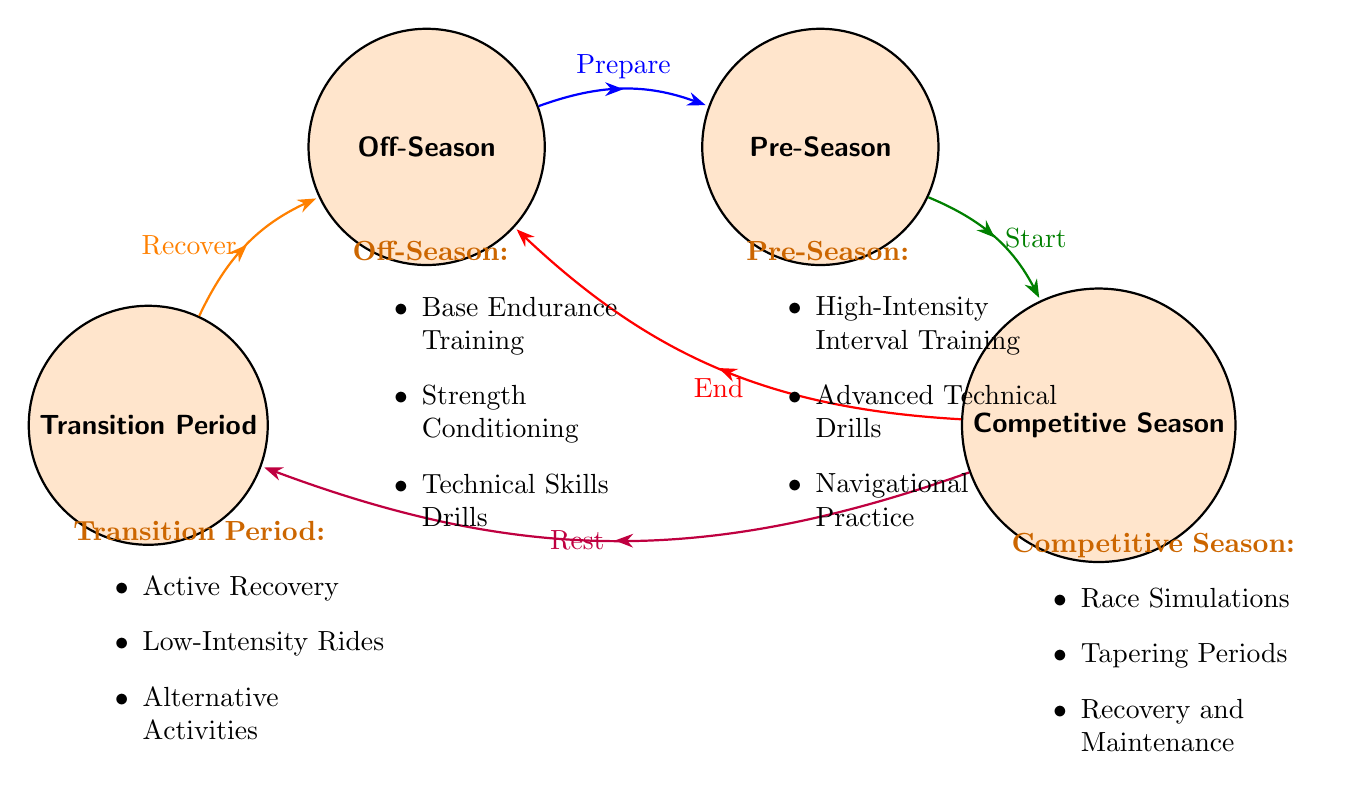What are the activities in the Off-Season? The Off-Season state lists three activities: Base Endurance Training, Strength Conditioning, and Technical Skills Drills.
Answer: Base Endurance Training, Strength Conditioning, Technical Skills Drills How many states are in the diagram? The diagram features four states: Off-Season, Pre-Season, Competitive Season, and Transition Period, making a total of four.
Answer: 4 What is the transition from Pre-Season to Competitive Season? The transition from Pre-Season to Competitive Season is indicated by the arrow labeled "Start."
Answer: Start Which state leads to the Transition Period? From the Competitive Season, there is a direct transition to the Transition Period, as shown by the arrow indicating "Rest."
Answer: Competitive Season What activities are performed during the Transition Period? The Transition Period includes Active Recovery, Low-Intensity Rides, and Alternative Activities (Swimming, Yoga).
Answer: Active Recovery, Low-Intensity Rides, Alternative Activities How many activities are there in the Competitive Season? The Competitive Season has three activities: Race Simulations, Tapering Periods, and Recovery and Maintenance. Therefore, there are three activities listed here.
Answer: 3 Which state has the transition labeled "End"? The transition labeled "End" leads back to the Off-Season from the Competitive Season, as indicated by the direction of the arrow.
Answer: Competitive Season What happens after the Competitive Season ends? Upon the end of the Competitive Season, the state transitions to the Off-Season as indicated by the "End" transition.
Answer: Off-Season What is the relationship between Transition Period and Off-Season? The Transition Period directly leads back to the Off-Season, which is shown by the arrow marked "Recover."
Answer: Transition Period to Off-Season 